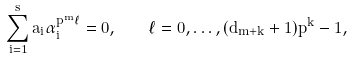<formula> <loc_0><loc_0><loc_500><loc_500>\sum _ { i = 1 } ^ { s } a _ { i } \alpha _ { i } ^ { p ^ { m } \ell } = 0 , \quad \ell = 0 , \dots , ( d _ { m + k } + 1 ) p ^ { k } - 1 ,</formula> 